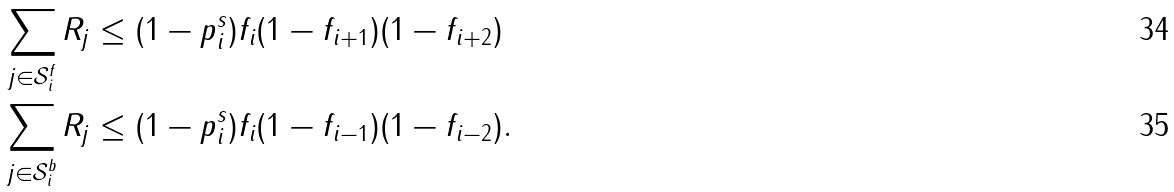<formula> <loc_0><loc_0><loc_500><loc_500>\sum _ { j \in \mathcal { S } _ { i } ^ { f } } R _ { j } & \leq ( 1 - p ^ { s } _ { i } ) f _ { i } ( 1 - f _ { i + 1 } ) ( 1 - f _ { i + 2 } ) \\ \sum _ { j \in \mathcal { S } _ { i } ^ { b } } R _ { j } & \leq ( 1 - p ^ { s } _ { i } ) f _ { i } ( 1 - f _ { i - 1 } ) ( 1 - f _ { i - 2 } ) .</formula> 